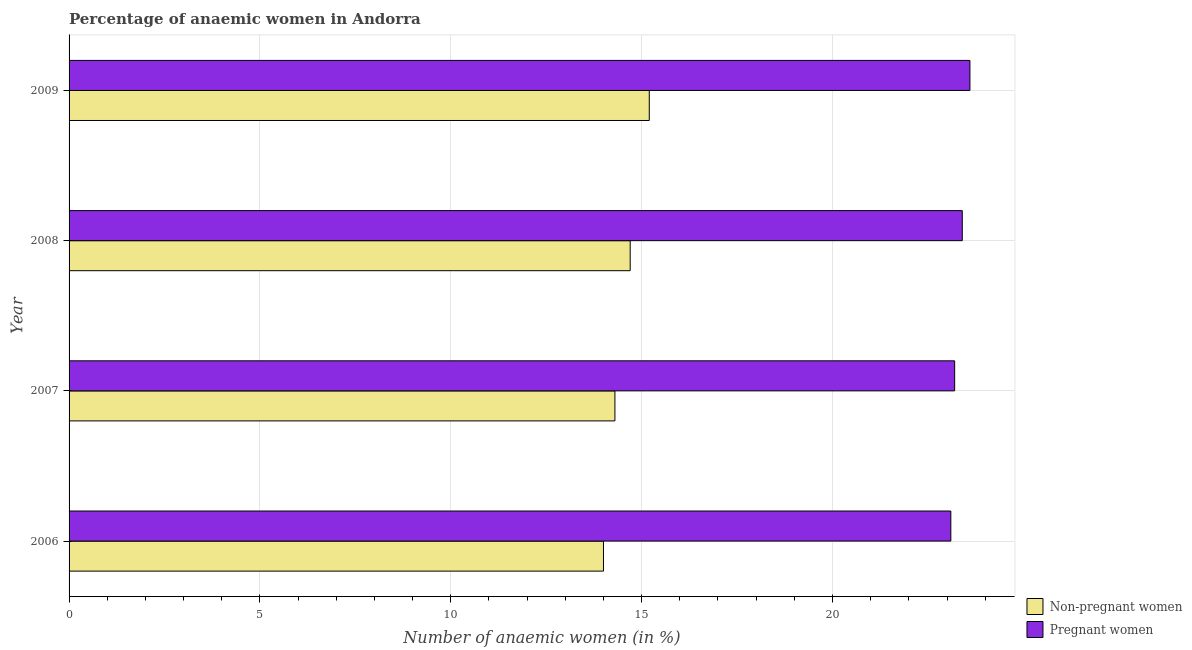How many different coloured bars are there?
Offer a very short reply. 2. How many groups of bars are there?
Keep it short and to the point. 4. Are the number of bars per tick equal to the number of legend labels?
Provide a short and direct response. Yes. Are the number of bars on each tick of the Y-axis equal?
Make the answer very short. Yes. In how many cases, is the number of bars for a given year not equal to the number of legend labels?
Offer a very short reply. 0. Across all years, what is the maximum percentage of non-pregnant anaemic women?
Your answer should be very brief. 15.2. In which year was the percentage of non-pregnant anaemic women maximum?
Provide a short and direct response. 2009. In which year was the percentage of non-pregnant anaemic women minimum?
Provide a short and direct response. 2006. What is the total percentage of pregnant anaemic women in the graph?
Your response must be concise. 93.3. What is the difference between the percentage of non-pregnant anaemic women in 2008 and that in 2009?
Your answer should be very brief. -0.5. What is the difference between the percentage of pregnant anaemic women in 2009 and the percentage of non-pregnant anaemic women in 2007?
Offer a very short reply. 9.3. What is the average percentage of pregnant anaemic women per year?
Give a very brief answer. 23.32. In the year 2008, what is the difference between the percentage of pregnant anaemic women and percentage of non-pregnant anaemic women?
Provide a short and direct response. 8.7. In how many years, is the percentage of pregnant anaemic women greater than 11 %?
Your answer should be very brief. 4. What is the ratio of the percentage of non-pregnant anaemic women in 2007 to that in 2009?
Your answer should be compact. 0.94. Is the percentage of non-pregnant anaemic women in 2006 less than that in 2008?
Provide a short and direct response. Yes. Is the difference between the percentage of pregnant anaemic women in 2007 and 2009 greater than the difference between the percentage of non-pregnant anaemic women in 2007 and 2009?
Your answer should be very brief. Yes. What is the difference between the highest and the lowest percentage of non-pregnant anaemic women?
Make the answer very short. 1.2. In how many years, is the percentage of non-pregnant anaemic women greater than the average percentage of non-pregnant anaemic women taken over all years?
Provide a succinct answer. 2. What does the 2nd bar from the top in 2006 represents?
Keep it short and to the point. Non-pregnant women. What does the 2nd bar from the bottom in 2006 represents?
Give a very brief answer. Pregnant women. How many bars are there?
Make the answer very short. 8. How many years are there in the graph?
Make the answer very short. 4. Does the graph contain any zero values?
Keep it short and to the point. No. Does the graph contain grids?
Your answer should be very brief. Yes. How many legend labels are there?
Offer a very short reply. 2. What is the title of the graph?
Provide a short and direct response. Percentage of anaemic women in Andorra. Does "Females" appear as one of the legend labels in the graph?
Make the answer very short. No. What is the label or title of the X-axis?
Give a very brief answer. Number of anaemic women (in %). What is the label or title of the Y-axis?
Provide a short and direct response. Year. What is the Number of anaemic women (in %) of Non-pregnant women in 2006?
Ensure brevity in your answer.  14. What is the Number of anaemic women (in %) of Pregnant women in 2006?
Your response must be concise. 23.1. What is the Number of anaemic women (in %) in Non-pregnant women in 2007?
Your answer should be compact. 14.3. What is the Number of anaemic women (in %) in Pregnant women in 2007?
Provide a short and direct response. 23.2. What is the Number of anaemic women (in %) of Pregnant women in 2008?
Keep it short and to the point. 23.4. What is the Number of anaemic women (in %) of Non-pregnant women in 2009?
Your answer should be very brief. 15.2. What is the Number of anaemic women (in %) of Pregnant women in 2009?
Provide a short and direct response. 23.6. Across all years, what is the maximum Number of anaemic women (in %) of Non-pregnant women?
Keep it short and to the point. 15.2. Across all years, what is the maximum Number of anaemic women (in %) in Pregnant women?
Your response must be concise. 23.6. Across all years, what is the minimum Number of anaemic women (in %) in Non-pregnant women?
Your answer should be very brief. 14. Across all years, what is the minimum Number of anaemic women (in %) in Pregnant women?
Your answer should be very brief. 23.1. What is the total Number of anaemic women (in %) of Non-pregnant women in the graph?
Ensure brevity in your answer.  58.2. What is the total Number of anaemic women (in %) in Pregnant women in the graph?
Your response must be concise. 93.3. What is the difference between the Number of anaemic women (in %) in Non-pregnant women in 2006 and that in 2007?
Ensure brevity in your answer.  -0.3. What is the difference between the Number of anaemic women (in %) of Pregnant women in 2006 and that in 2007?
Give a very brief answer. -0.1. What is the difference between the Number of anaemic women (in %) in Non-pregnant women in 2007 and that in 2008?
Your response must be concise. -0.4. What is the difference between the Number of anaemic women (in %) in Pregnant women in 2007 and that in 2008?
Make the answer very short. -0.2. What is the difference between the Number of anaemic women (in %) of Non-pregnant women in 2007 and that in 2009?
Offer a terse response. -0.9. What is the difference between the Number of anaemic women (in %) of Pregnant women in 2007 and that in 2009?
Provide a succinct answer. -0.4. What is the difference between the Number of anaemic women (in %) in Pregnant women in 2008 and that in 2009?
Give a very brief answer. -0.2. What is the difference between the Number of anaemic women (in %) in Non-pregnant women in 2006 and the Number of anaemic women (in %) in Pregnant women in 2007?
Provide a short and direct response. -9.2. What is the difference between the Number of anaemic women (in %) in Non-pregnant women in 2006 and the Number of anaemic women (in %) in Pregnant women in 2008?
Offer a very short reply. -9.4. What is the difference between the Number of anaemic women (in %) in Non-pregnant women in 2006 and the Number of anaemic women (in %) in Pregnant women in 2009?
Keep it short and to the point. -9.6. What is the difference between the Number of anaemic women (in %) of Non-pregnant women in 2007 and the Number of anaemic women (in %) of Pregnant women in 2008?
Keep it short and to the point. -9.1. What is the difference between the Number of anaemic women (in %) in Non-pregnant women in 2008 and the Number of anaemic women (in %) in Pregnant women in 2009?
Provide a short and direct response. -8.9. What is the average Number of anaemic women (in %) of Non-pregnant women per year?
Offer a very short reply. 14.55. What is the average Number of anaemic women (in %) of Pregnant women per year?
Your response must be concise. 23.32. In the year 2008, what is the difference between the Number of anaemic women (in %) of Non-pregnant women and Number of anaemic women (in %) of Pregnant women?
Ensure brevity in your answer.  -8.7. What is the ratio of the Number of anaemic women (in %) of Non-pregnant women in 2006 to that in 2007?
Keep it short and to the point. 0.98. What is the ratio of the Number of anaemic women (in %) in Non-pregnant women in 2006 to that in 2008?
Your response must be concise. 0.95. What is the ratio of the Number of anaemic women (in %) in Pregnant women in 2006 to that in 2008?
Make the answer very short. 0.99. What is the ratio of the Number of anaemic women (in %) of Non-pregnant women in 2006 to that in 2009?
Provide a short and direct response. 0.92. What is the ratio of the Number of anaemic women (in %) in Pregnant women in 2006 to that in 2009?
Ensure brevity in your answer.  0.98. What is the ratio of the Number of anaemic women (in %) in Non-pregnant women in 2007 to that in 2008?
Give a very brief answer. 0.97. What is the ratio of the Number of anaemic women (in %) of Non-pregnant women in 2007 to that in 2009?
Ensure brevity in your answer.  0.94. What is the ratio of the Number of anaemic women (in %) of Pregnant women in 2007 to that in 2009?
Your response must be concise. 0.98. What is the ratio of the Number of anaemic women (in %) in Non-pregnant women in 2008 to that in 2009?
Your answer should be compact. 0.97. 